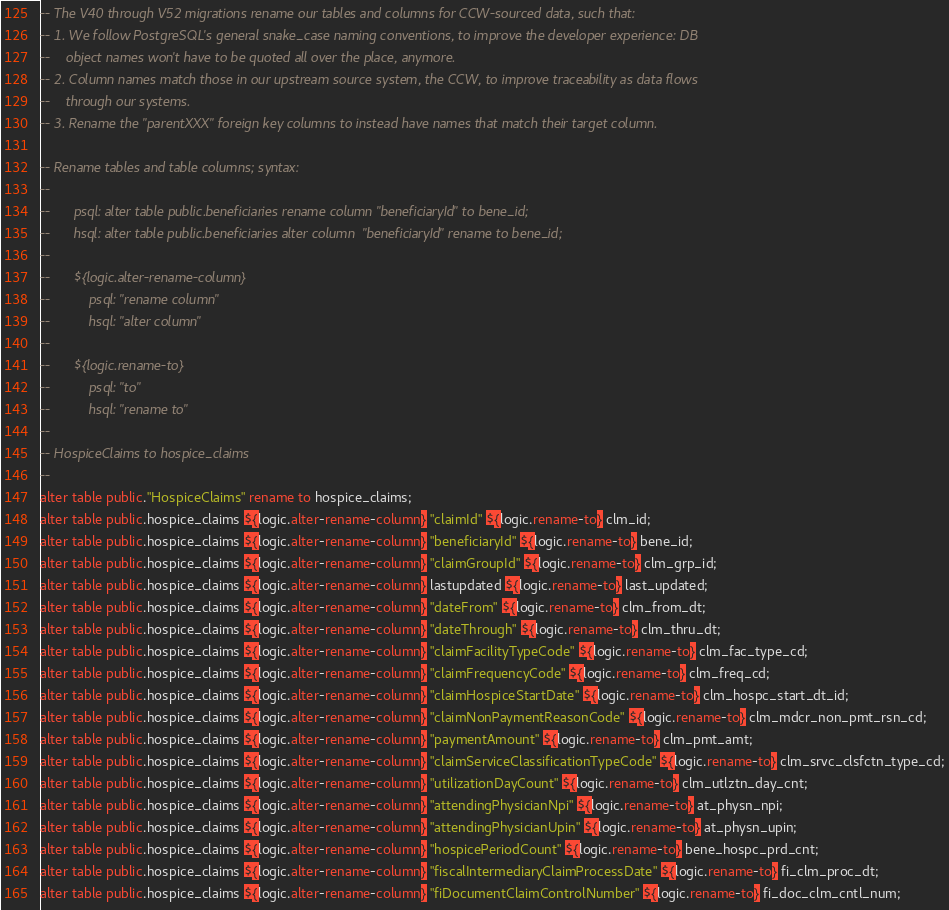<code> <loc_0><loc_0><loc_500><loc_500><_SQL_>-- The V40 through V52 migrations rename our tables and columns for CCW-sourced data, such that:
-- 1. We follow PostgreSQL's general snake_case naming conventions, to improve the developer experience: DB
--    object names won't have to be quoted all over the place, anymore.
-- 2. Column names match those in our upstream source system, the CCW, to improve traceability as data flows
--    through our systems.
-- 3. Rename the "parentXXX" foreign key columns to instead have names that match their target column.

-- Rename tables and table columns; syntax:
--
--      psql: alter table public.beneficiaries rename column "beneficiaryId" to bene_id;
--      hsql: alter table public.beneficiaries alter column  "beneficiaryId" rename to bene_id;
--
--      ${logic.alter-rename-column}
--          psql: "rename column"
--          hsql: "alter column"
--
--      ${logic.rename-to}
--          psql: "to"
--          hsql: "rename to"
--
-- HospiceClaims to hospice_claims
--
alter table public."HospiceClaims" rename to hospice_claims;
alter table public.hospice_claims ${logic.alter-rename-column} "claimId" ${logic.rename-to} clm_id;
alter table public.hospice_claims ${logic.alter-rename-column} "beneficiaryId" ${logic.rename-to} bene_id;
alter table public.hospice_claims ${logic.alter-rename-column} "claimGroupId" ${logic.rename-to} clm_grp_id;
alter table public.hospice_claims ${logic.alter-rename-column} lastupdated ${logic.rename-to} last_updated;
alter table public.hospice_claims ${logic.alter-rename-column} "dateFrom" ${logic.rename-to} clm_from_dt;
alter table public.hospice_claims ${logic.alter-rename-column} "dateThrough" ${logic.rename-to} clm_thru_dt;
alter table public.hospice_claims ${logic.alter-rename-column} "claimFacilityTypeCode" ${logic.rename-to} clm_fac_type_cd;
alter table public.hospice_claims ${logic.alter-rename-column} "claimFrequencyCode" ${logic.rename-to} clm_freq_cd;
alter table public.hospice_claims ${logic.alter-rename-column} "claimHospiceStartDate" ${logic.rename-to} clm_hospc_start_dt_id;
alter table public.hospice_claims ${logic.alter-rename-column} "claimNonPaymentReasonCode" ${logic.rename-to} clm_mdcr_non_pmt_rsn_cd;
alter table public.hospice_claims ${logic.alter-rename-column} "paymentAmount" ${logic.rename-to} clm_pmt_amt;
alter table public.hospice_claims ${logic.alter-rename-column} "claimServiceClassificationTypeCode" ${logic.rename-to} clm_srvc_clsfctn_type_cd;
alter table public.hospice_claims ${logic.alter-rename-column} "utilizationDayCount" ${logic.rename-to} clm_utlztn_day_cnt;
alter table public.hospice_claims ${logic.alter-rename-column} "attendingPhysicianNpi" ${logic.rename-to} at_physn_npi;
alter table public.hospice_claims ${logic.alter-rename-column} "attendingPhysicianUpin" ${logic.rename-to} at_physn_upin;
alter table public.hospice_claims ${logic.alter-rename-column} "hospicePeriodCount" ${logic.rename-to} bene_hospc_prd_cnt;
alter table public.hospice_claims ${logic.alter-rename-column} "fiscalIntermediaryClaimProcessDate" ${logic.rename-to} fi_clm_proc_dt;
alter table public.hospice_claims ${logic.alter-rename-column} "fiDocumentClaimControlNumber" ${logic.rename-to} fi_doc_clm_cntl_num;</code> 